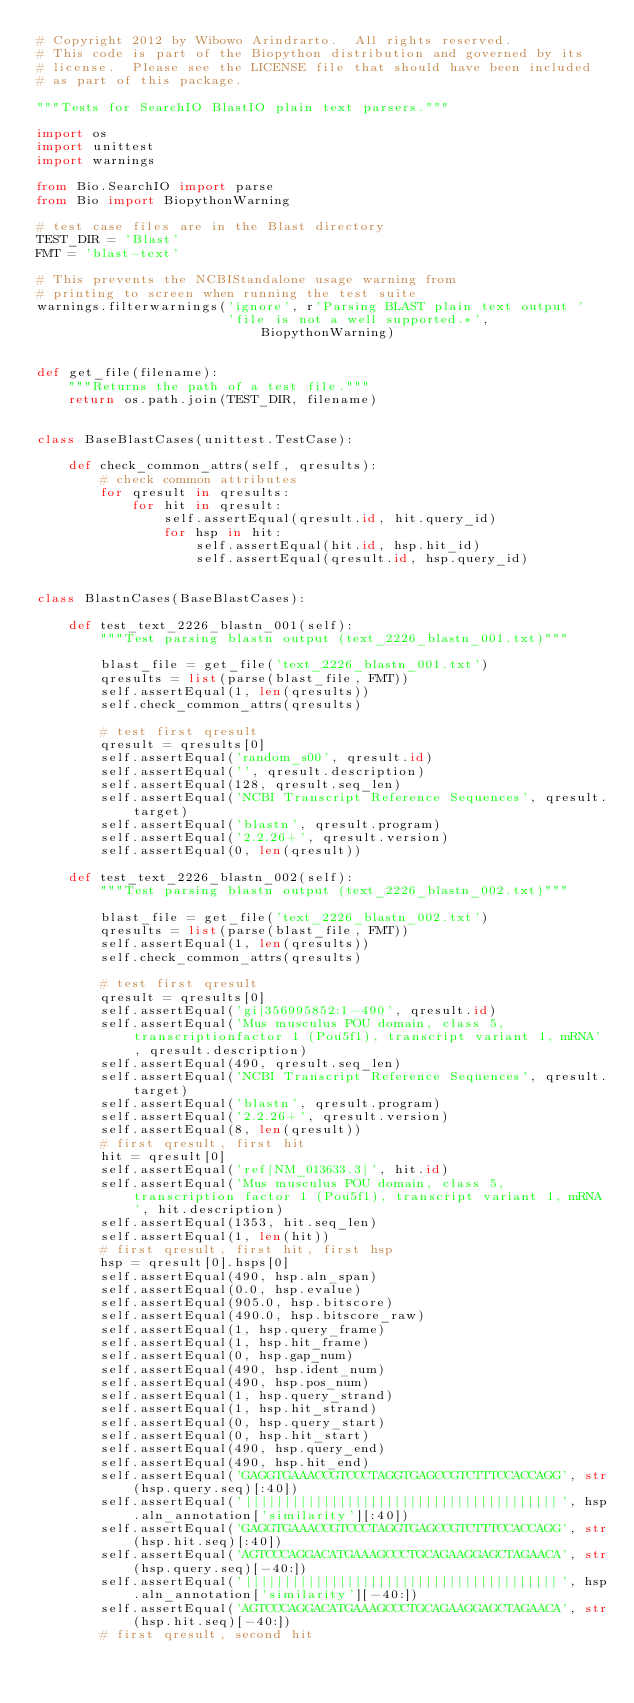Convert code to text. <code><loc_0><loc_0><loc_500><loc_500><_Python_># Copyright 2012 by Wibowo Arindrarto.  All rights reserved.
# This code is part of the Biopython distribution and governed by its
# license.  Please see the LICENSE file that should have been included
# as part of this package.

"""Tests for SearchIO BlastIO plain text parsers."""

import os
import unittest
import warnings

from Bio.SearchIO import parse
from Bio import BiopythonWarning

# test case files are in the Blast directory
TEST_DIR = 'Blast'
FMT = 'blast-text'

# This prevents the NCBIStandalone usage warning from
# printing to screen when running the test suite
warnings.filterwarnings('ignore', r'Parsing BLAST plain text output '
                        'file is not a well supported.*', BiopythonWarning)


def get_file(filename):
    """Returns the path of a test file."""
    return os.path.join(TEST_DIR, filename)


class BaseBlastCases(unittest.TestCase):

    def check_common_attrs(self, qresults):
        # check common attributes
        for qresult in qresults:
            for hit in qresult:
                self.assertEqual(qresult.id, hit.query_id)
                for hsp in hit:
                    self.assertEqual(hit.id, hsp.hit_id)
                    self.assertEqual(qresult.id, hsp.query_id)


class BlastnCases(BaseBlastCases):

    def test_text_2226_blastn_001(self):
        """Test parsing blastn output (text_2226_blastn_001.txt)"""

        blast_file = get_file('text_2226_blastn_001.txt')
        qresults = list(parse(blast_file, FMT))
        self.assertEqual(1, len(qresults))
        self.check_common_attrs(qresults)

        # test first qresult
        qresult = qresults[0]
        self.assertEqual('random_s00', qresult.id)
        self.assertEqual('', qresult.description)
        self.assertEqual(128, qresult.seq_len)
        self.assertEqual('NCBI Transcript Reference Sequences', qresult.target)
        self.assertEqual('blastn', qresult.program)
        self.assertEqual('2.2.26+', qresult.version)
        self.assertEqual(0, len(qresult))

    def test_text_2226_blastn_002(self):
        """Test parsing blastn output (text_2226_blastn_002.txt)"""

        blast_file = get_file('text_2226_blastn_002.txt')
        qresults = list(parse(blast_file, FMT))
        self.assertEqual(1, len(qresults))
        self.check_common_attrs(qresults)

        # test first qresult
        qresult = qresults[0]
        self.assertEqual('gi|356995852:1-490', qresult.id)
        self.assertEqual('Mus musculus POU domain, class 5, transcriptionfactor 1 (Pou5f1), transcript variant 1, mRNA', qresult.description)
        self.assertEqual(490, qresult.seq_len)
        self.assertEqual('NCBI Transcript Reference Sequences', qresult.target)
        self.assertEqual('blastn', qresult.program)
        self.assertEqual('2.2.26+', qresult.version)
        self.assertEqual(8, len(qresult))
        # first qresult, first hit
        hit = qresult[0]
        self.assertEqual('ref|NM_013633.3|', hit.id)
        self.assertEqual('Mus musculus POU domain, class 5, transcription factor 1 (Pou5f1), transcript variant 1, mRNA', hit.description)
        self.assertEqual(1353, hit.seq_len)
        self.assertEqual(1, len(hit))
        # first qresult, first hit, first hsp
        hsp = qresult[0].hsps[0]
        self.assertEqual(490, hsp.aln_span)
        self.assertEqual(0.0, hsp.evalue)
        self.assertEqual(905.0, hsp.bitscore)
        self.assertEqual(490.0, hsp.bitscore_raw)
        self.assertEqual(1, hsp.query_frame)
        self.assertEqual(1, hsp.hit_frame)
        self.assertEqual(0, hsp.gap_num)
        self.assertEqual(490, hsp.ident_num)
        self.assertEqual(490, hsp.pos_num)
        self.assertEqual(1, hsp.query_strand)
        self.assertEqual(1, hsp.hit_strand)
        self.assertEqual(0, hsp.query_start)
        self.assertEqual(0, hsp.hit_start)
        self.assertEqual(490, hsp.query_end)
        self.assertEqual(490, hsp.hit_end)
        self.assertEqual('GAGGTGAAACCGTCCCTAGGTGAGCCGTCTTTCCACCAGG', str(hsp.query.seq)[:40])
        self.assertEqual('||||||||||||||||||||||||||||||||||||||||', hsp.aln_annotation['similarity'][:40])
        self.assertEqual('GAGGTGAAACCGTCCCTAGGTGAGCCGTCTTTCCACCAGG', str(hsp.hit.seq)[:40])
        self.assertEqual('AGTCCCAGGACATGAAAGCCCTGCAGAAGGAGCTAGAACA', str(hsp.query.seq)[-40:])
        self.assertEqual('||||||||||||||||||||||||||||||||||||||||', hsp.aln_annotation['similarity'][-40:])
        self.assertEqual('AGTCCCAGGACATGAAAGCCCTGCAGAAGGAGCTAGAACA', str(hsp.hit.seq)[-40:])
        # first qresult, second hit</code> 